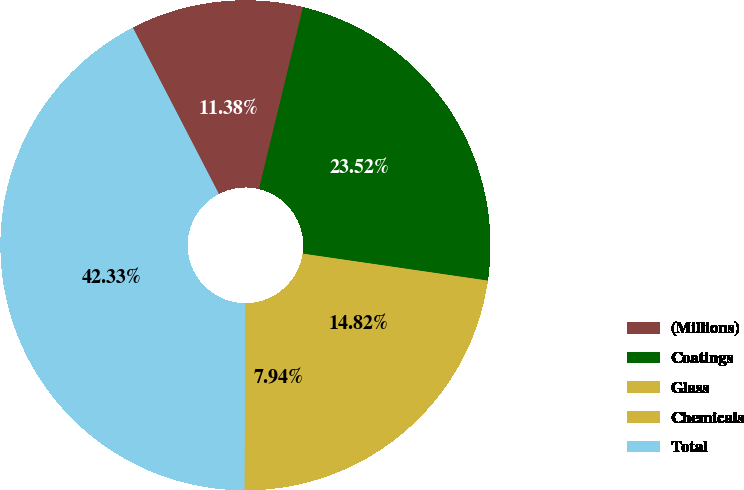<chart> <loc_0><loc_0><loc_500><loc_500><pie_chart><fcel>(Millions)<fcel>Coatings<fcel>Glass<fcel>Chemicals<fcel>Total<nl><fcel>11.38%<fcel>23.52%<fcel>14.82%<fcel>7.94%<fcel>42.33%<nl></chart> 